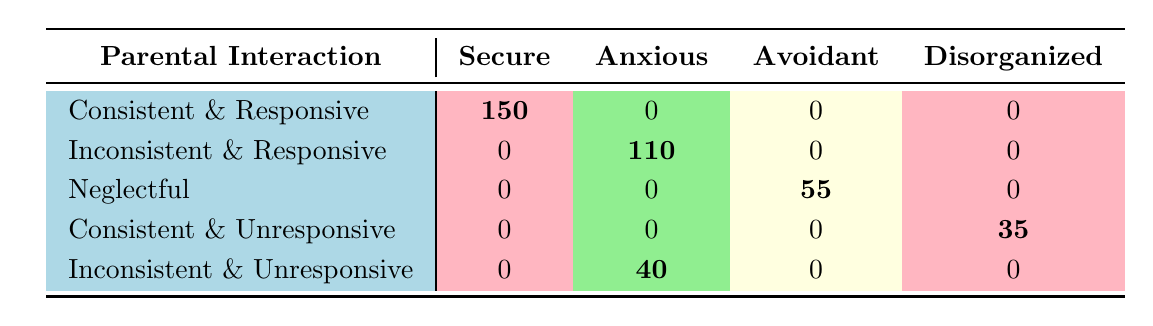What is the total count of secure attachment styles based on parental interaction? To find the total count of secure attachment styles, we look at the "Secure" column in the table. The only relevant row is "Consistent & Responsive", which has a count of 150. Therefore, the total is 150.
Answer: 150 How many attachment styles are classified as anxious based on inconsistent parental interaction? The table indicates there are two instances of anxious attachment styles under "Inconsistent" parental interactions: one for "Inconsistent & Responsive" (count 110) and one for "Inconsistent & Unresponsive" (count 40). Adding those, we get 110 + 40 = 150.
Answer: 150 Which parental interaction style has the highest count for avoidant attachment? Upon examining the "Avoidant" column, we find that "Neglectful" has the highest count at 55, while "Inconsistent & Responsive" has no avoidant cases according to the data. Therefore, "Neglectful" is the highest.
Answer: Neglectful Is there any parental interaction style that leads to a disorganized attachment style? Yes, the parental interaction "Consistent & Unresponsive" shows a count of 35 for the disorganized attachment style, confirming that this interaction leads to such an attachment style.
Answer: Yes What is the difference in counts between secure and anxious attachment styles across all parental interactions? The total count of secure attachment styles is 150, and the total count of anxious attachment styles is 150. Therefore, the difference is calculated as 150 - 150 = 0.
Answer: 0 What is the average count of attachment styles that lead to avoidant attachments based on various parental interactions? Analyzing the avoidant attachment style, we find two counts: 55 from "Neglectful" and 0 for the others. The total is 55, and since there are 3 data points, we calculate the average as 55/3 = 18.33 (approximately).
Answer: 18.33 Which parental interaction style results in the lowest attachment style count overall? Checking through the table, "Consistent & Unresponsive" yields a disorganized count of 35, while all other interactions either have higher counts or no counts. Hence, "Consistent & Unresponsive" has the lowest attachment style count overall.
Answer: Consistent & Unresponsive How many attachment styles fall under responsive parental interactions compared to unresponsive ones? In the table, "Responsive" interactions lead to 150 (consistent) and 110 (inconsistent) for secure and anxious total 260. "Unresponsive" interactions show 35 (consistent) and 40 (inconsistent) for disorganized and anxious total 75. Thus 260 (responsive) is greater than 75 (unresponsive).
Answer: Responsive has more 